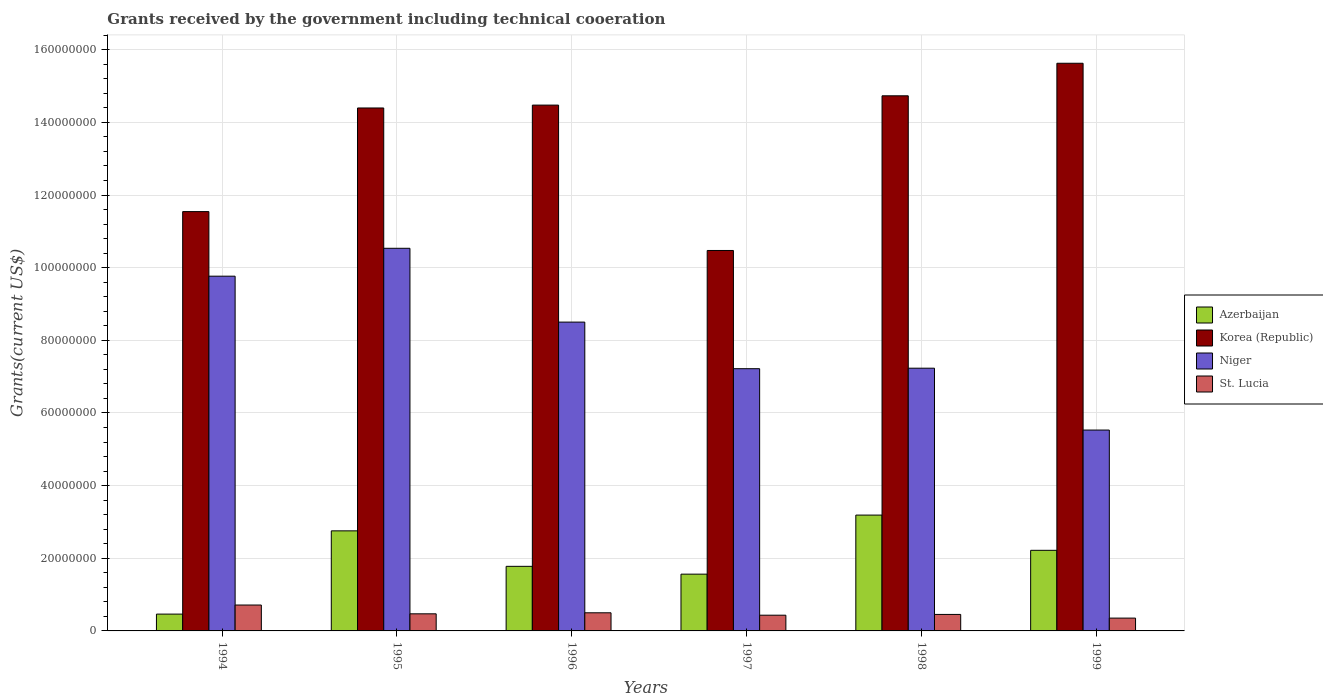How many bars are there on the 4th tick from the left?
Your response must be concise. 4. How many bars are there on the 4th tick from the right?
Make the answer very short. 4. In how many cases, is the number of bars for a given year not equal to the number of legend labels?
Your answer should be compact. 0. What is the total grants received by the government in Niger in 1997?
Offer a very short reply. 7.22e+07. Across all years, what is the maximum total grants received by the government in St. Lucia?
Provide a short and direct response. 7.13e+06. Across all years, what is the minimum total grants received by the government in Niger?
Provide a short and direct response. 5.53e+07. In which year was the total grants received by the government in Korea (Republic) maximum?
Provide a succinct answer. 1999. In which year was the total grants received by the government in Korea (Republic) minimum?
Your answer should be compact. 1997. What is the total total grants received by the government in Azerbaijan in the graph?
Your answer should be compact. 1.20e+08. What is the difference between the total grants received by the government in St. Lucia in 1994 and that in 1996?
Offer a terse response. 2.14e+06. What is the difference between the total grants received by the government in Korea (Republic) in 1998 and the total grants received by the government in St. Lucia in 1995?
Keep it short and to the point. 1.43e+08. What is the average total grants received by the government in Korea (Republic) per year?
Give a very brief answer. 1.35e+08. In the year 1997, what is the difference between the total grants received by the government in St. Lucia and total grants received by the government in Niger?
Your answer should be compact. -6.79e+07. In how many years, is the total grants received by the government in St. Lucia greater than 96000000 US$?
Your response must be concise. 0. What is the ratio of the total grants received by the government in St. Lucia in 1997 to that in 1998?
Offer a very short reply. 0.95. Is the total grants received by the government in Korea (Republic) in 1994 less than that in 1998?
Keep it short and to the point. Yes. What is the difference between the highest and the second highest total grants received by the government in Niger?
Make the answer very short. 7.68e+06. What is the difference between the highest and the lowest total grants received by the government in Niger?
Keep it short and to the point. 5.00e+07. Is the sum of the total grants received by the government in St. Lucia in 1994 and 1996 greater than the maximum total grants received by the government in Niger across all years?
Your answer should be compact. No. Is it the case that in every year, the sum of the total grants received by the government in Niger and total grants received by the government in St. Lucia is greater than the sum of total grants received by the government in Azerbaijan and total grants received by the government in Korea (Republic)?
Provide a short and direct response. No. What does the 2nd bar from the left in 1999 represents?
Offer a very short reply. Korea (Republic). Is it the case that in every year, the sum of the total grants received by the government in Niger and total grants received by the government in Azerbaijan is greater than the total grants received by the government in St. Lucia?
Ensure brevity in your answer.  Yes. How many bars are there?
Give a very brief answer. 24. How many years are there in the graph?
Offer a terse response. 6. What is the difference between two consecutive major ticks on the Y-axis?
Your answer should be very brief. 2.00e+07. Where does the legend appear in the graph?
Keep it short and to the point. Center right. How are the legend labels stacked?
Your answer should be very brief. Vertical. What is the title of the graph?
Offer a very short reply. Grants received by the government including technical cooeration. Does "Germany" appear as one of the legend labels in the graph?
Keep it short and to the point. No. What is the label or title of the X-axis?
Provide a short and direct response. Years. What is the label or title of the Y-axis?
Give a very brief answer. Grants(current US$). What is the Grants(current US$) in Azerbaijan in 1994?
Provide a short and direct response. 4.63e+06. What is the Grants(current US$) of Korea (Republic) in 1994?
Your answer should be very brief. 1.15e+08. What is the Grants(current US$) of Niger in 1994?
Your answer should be compact. 9.77e+07. What is the Grants(current US$) of St. Lucia in 1994?
Ensure brevity in your answer.  7.13e+06. What is the Grants(current US$) in Azerbaijan in 1995?
Your response must be concise. 2.76e+07. What is the Grants(current US$) of Korea (Republic) in 1995?
Ensure brevity in your answer.  1.44e+08. What is the Grants(current US$) of Niger in 1995?
Your response must be concise. 1.05e+08. What is the Grants(current US$) in St. Lucia in 1995?
Offer a very short reply. 4.71e+06. What is the Grants(current US$) of Azerbaijan in 1996?
Your response must be concise. 1.78e+07. What is the Grants(current US$) in Korea (Republic) in 1996?
Keep it short and to the point. 1.45e+08. What is the Grants(current US$) of Niger in 1996?
Give a very brief answer. 8.50e+07. What is the Grants(current US$) in St. Lucia in 1996?
Keep it short and to the point. 4.99e+06. What is the Grants(current US$) in Azerbaijan in 1997?
Provide a short and direct response. 1.56e+07. What is the Grants(current US$) in Korea (Republic) in 1997?
Give a very brief answer. 1.05e+08. What is the Grants(current US$) of Niger in 1997?
Keep it short and to the point. 7.22e+07. What is the Grants(current US$) in St. Lucia in 1997?
Give a very brief answer. 4.33e+06. What is the Grants(current US$) in Azerbaijan in 1998?
Give a very brief answer. 3.19e+07. What is the Grants(current US$) of Korea (Republic) in 1998?
Provide a succinct answer. 1.47e+08. What is the Grants(current US$) of Niger in 1998?
Your response must be concise. 7.23e+07. What is the Grants(current US$) of St. Lucia in 1998?
Make the answer very short. 4.54e+06. What is the Grants(current US$) in Azerbaijan in 1999?
Offer a very short reply. 2.22e+07. What is the Grants(current US$) of Korea (Republic) in 1999?
Provide a succinct answer. 1.56e+08. What is the Grants(current US$) in Niger in 1999?
Keep it short and to the point. 5.53e+07. What is the Grants(current US$) in St. Lucia in 1999?
Keep it short and to the point. 3.53e+06. Across all years, what is the maximum Grants(current US$) in Azerbaijan?
Offer a terse response. 3.19e+07. Across all years, what is the maximum Grants(current US$) in Korea (Republic)?
Provide a succinct answer. 1.56e+08. Across all years, what is the maximum Grants(current US$) of Niger?
Offer a very short reply. 1.05e+08. Across all years, what is the maximum Grants(current US$) of St. Lucia?
Offer a very short reply. 7.13e+06. Across all years, what is the minimum Grants(current US$) in Azerbaijan?
Provide a short and direct response. 4.63e+06. Across all years, what is the minimum Grants(current US$) of Korea (Republic)?
Ensure brevity in your answer.  1.05e+08. Across all years, what is the minimum Grants(current US$) of Niger?
Keep it short and to the point. 5.53e+07. Across all years, what is the minimum Grants(current US$) in St. Lucia?
Your answer should be very brief. 3.53e+06. What is the total Grants(current US$) in Azerbaijan in the graph?
Offer a very short reply. 1.20e+08. What is the total Grants(current US$) in Korea (Republic) in the graph?
Offer a terse response. 8.13e+08. What is the total Grants(current US$) of Niger in the graph?
Offer a terse response. 4.88e+08. What is the total Grants(current US$) in St. Lucia in the graph?
Your answer should be compact. 2.92e+07. What is the difference between the Grants(current US$) in Azerbaijan in 1994 and that in 1995?
Make the answer very short. -2.29e+07. What is the difference between the Grants(current US$) in Korea (Republic) in 1994 and that in 1995?
Ensure brevity in your answer.  -2.85e+07. What is the difference between the Grants(current US$) of Niger in 1994 and that in 1995?
Give a very brief answer. -7.68e+06. What is the difference between the Grants(current US$) in St. Lucia in 1994 and that in 1995?
Provide a short and direct response. 2.42e+06. What is the difference between the Grants(current US$) of Azerbaijan in 1994 and that in 1996?
Provide a succinct answer. -1.32e+07. What is the difference between the Grants(current US$) in Korea (Republic) in 1994 and that in 1996?
Provide a short and direct response. -2.93e+07. What is the difference between the Grants(current US$) of Niger in 1994 and that in 1996?
Make the answer very short. 1.26e+07. What is the difference between the Grants(current US$) of St. Lucia in 1994 and that in 1996?
Offer a terse response. 2.14e+06. What is the difference between the Grants(current US$) of Azerbaijan in 1994 and that in 1997?
Your response must be concise. -1.10e+07. What is the difference between the Grants(current US$) in Korea (Republic) in 1994 and that in 1997?
Provide a succinct answer. 1.07e+07. What is the difference between the Grants(current US$) of Niger in 1994 and that in 1997?
Give a very brief answer. 2.55e+07. What is the difference between the Grants(current US$) in St. Lucia in 1994 and that in 1997?
Offer a very short reply. 2.80e+06. What is the difference between the Grants(current US$) of Azerbaijan in 1994 and that in 1998?
Ensure brevity in your answer.  -2.73e+07. What is the difference between the Grants(current US$) in Korea (Republic) in 1994 and that in 1998?
Your answer should be compact. -3.19e+07. What is the difference between the Grants(current US$) in Niger in 1994 and that in 1998?
Make the answer very short. 2.53e+07. What is the difference between the Grants(current US$) of St. Lucia in 1994 and that in 1998?
Your response must be concise. 2.59e+06. What is the difference between the Grants(current US$) in Azerbaijan in 1994 and that in 1999?
Make the answer very short. -1.76e+07. What is the difference between the Grants(current US$) of Korea (Republic) in 1994 and that in 1999?
Provide a succinct answer. -4.08e+07. What is the difference between the Grants(current US$) in Niger in 1994 and that in 1999?
Provide a short and direct response. 4.24e+07. What is the difference between the Grants(current US$) of St. Lucia in 1994 and that in 1999?
Provide a succinct answer. 3.60e+06. What is the difference between the Grants(current US$) in Azerbaijan in 1995 and that in 1996?
Offer a very short reply. 9.77e+06. What is the difference between the Grants(current US$) in Korea (Republic) in 1995 and that in 1996?
Your response must be concise. -7.90e+05. What is the difference between the Grants(current US$) in Niger in 1995 and that in 1996?
Your answer should be very brief. 2.03e+07. What is the difference between the Grants(current US$) of St. Lucia in 1995 and that in 1996?
Offer a very short reply. -2.80e+05. What is the difference between the Grants(current US$) of Azerbaijan in 1995 and that in 1997?
Keep it short and to the point. 1.19e+07. What is the difference between the Grants(current US$) in Korea (Republic) in 1995 and that in 1997?
Provide a succinct answer. 3.92e+07. What is the difference between the Grants(current US$) in Niger in 1995 and that in 1997?
Provide a succinct answer. 3.32e+07. What is the difference between the Grants(current US$) in St. Lucia in 1995 and that in 1997?
Keep it short and to the point. 3.80e+05. What is the difference between the Grants(current US$) in Azerbaijan in 1995 and that in 1998?
Your answer should be compact. -4.34e+06. What is the difference between the Grants(current US$) of Korea (Republic) in 1995 and that in 1998?
Your answer should be compact. -3.35e+06. What is the difference between the Grants(current US$) of Niger in 1995 and that in 1998?
Make the answer very short. 3.30e+07. What is the difference between the Grants(current US$) in Azerbaijan in 1995 and that in 1999?
Keep it short and to the point. 5.36e+06. What is the difference between the Grants(current US$) in Korea (Republic) in 1995 and that in 1999?
Your response must be concise. -1.23e+07. What is the difference between the Grants(current US$) of Niger in 1995 and that in 1999?
Provide a short and direct response. 5.00e+07. What is the difference between the Grants(current US$) in St. Lucia in 1995 and that in 1999?
Provide a succinct answer. 1.18e+06. What is the difference between the Grants(current US$) in Azerbaijan in 1996 and that in 1997?
Offer a terse response. 2.15e+06. What is the difference between the Grants(current US$) of Korea (Republic) in 1996 and that in 1997?
Offer a terse response. 4.00e+07. What is the difference between the Grants(current US$) in Niger in 1996 and that in 1997?
Give a very brief answer. 1.28e+07. What is the difference between the Grants(current US$) in Azerbaijan in 1996 and that in 1998?
Your answer should be very brief. -1.41e+07. What is the difference between the Grants(current US$) in Korea (Republic) in 1996 and that in 1998?
Make the answer very short. -2.56e+06. What is the difference between the Grants(current US$) in Niger in 1996 and that in 1998?
Offer a terse response. 1.27e+07. What is the difference between the Grants(current US$) in Azerbaijan in 1996 and that in 1999?
Your response must be concise. -4.41e+06. What is the difference between the Grants(current US$) of Korea (Republic) in 1996 and that in 1999?
Provide a succinct answer. -1.15e+07. What is the difference between the Grants(current US$) in Niger in 1996 and that in 1999?
Provide a short and direct response. 2.97e+07. What is the difference between the Grants(current US$) in St. Lucia in 1996 and that in 1999?
Provide a short and direct response. 1.46e+06. What is the difference between the Grants(current US$) of Azerbaijan in 1997 and that in 1998?
Your answer should be very brief. -1.63e+07. What is the difference between the Grants(current US$) of Korea (Republic) in 1997 and that in 1998?
Offer a terse response. -4.26e+07. What is the difference between the Grants(current US$) of Azerbaijan in 1997 and that in 1999?
Your response must be concise. -6.56e+06. What is the difference between the Grants(current US$) of Korea (Republic) in 1997 and that in 1999?
Your answer should be very brief. -5.15e+07. What is the difference between the Grants(current US$) of Niger in 1997 and that in 1999?
Give a very brief answer. 1.69e+07. What is the difference between the Grants(current US$) of Azerbaijan in 1998 and that in 1999?
Keep it short and to the point. 9.70e+06. What is the difference between the Grants(current US$) of Korea (Republic) in 1998 and that in 1999?
Make the answer very short. -8.96e+06. What is the difference between the Grants(current US$) of Niger in 1998 and that in 1999?
Offer a terse response. 1.70e+07. What is the difference between the Grants(current US$) of St. Lucia in 1998 and that in 1999?
Give a very brief answer. 1.01e+06. What is the difference between the Grants(current US$) in Azerbaijan in 1994 and the Grants(current US$) in Korea (Republic) in 1995?
Ensure brevity in your answer.  -1.39e+08. What is the difference between the Grants(current US$) in Azerbaijan in 1994 and the Grants(current US$) in Niger in 1995?
Give a very brief answer. -1.01e+08. What is the difference between the Grants(current US$) of Korea (Republic) in 1994 and the Grants(current US$) of Niger in 1995?
Offer a very short reply. 1.01e+07. What is the difference between the Grants(current US$) of Korea (Republic) in 1994 and the Grants(current US$) of St. Lucia in 1995?
Offer a terse response. 1.11e+08. What is the difference between the Grants(current US$) of Niger in 1994 and the Grants(current US$) of St. Lucia in 1995?
Make the answer very short. 9.30e+07. What is the difference between the Grants(current US$) in Azerbaijan in 1994 and the Grants(current US$) in Korea (Republic) in 1996?
Make the answer very short. -1.40e+08. What is the difference between the Grants(current US$) of Azerbaijan in 1994 and the Grants(current US$) of Niger in 1996?
Provide a short and direct response. -8.04e+07. What is the difference between the Grants(current US$) in Azerbaijan in 1994 and the Grants(current US$) in St. Lucia in 1996?
Give a very brief answer. -3.60e+05. What is the difference between the Grants(current US$) in Korea (Republic) in 1994 and the Grants(current US$) in Niger in 1996?
Your answer should be compact. 3.04e+07. What is the difference between the Grants(current US$) of Korea (Republic) in 1994 and the Grants(current US$) of St. Lucia in 1996?
Your answer should be very brief. 1.10e+08. What is the difference between the Grants(current US$) of Niger in 1994 and the Grants(current US$) of St. Lucia in 1996?
Offer a very short reply. 9.27e+07. What is the difference between the Grants(current US$) of Azerbaijan in 1994 and the Grants(current US$) of Korea (Republic) in 1997?
Your answer should be very brief. -1.00e+08. What is the difference between the Grants(current US$) in Azerbaijan in 1994 and the Grants(current US$) in Niger in 1997?
Make the answer very short. -6.76e+07. What is the difference between the Grants(current US$) of Korea (Republic) in 1994 and the Grants(current US$) of Niger in 1997?
Your answer should be very brief. 4.32e+07. What is the difference between the Grants(current US$) of Korea (Republic) in 1994 and the Grants(current US$) of St. Lucia in 1997?
Your answer should be compact. 1.11e+08. What is the difference between the Grants(current US$) in Niger in 1994 and the Grants(current US$) in St. Lucia in 1997?
Ensure brevity in your answer.  9.33e+07. What is the difference between the Grants(current US$) of Azerbaijan in 1994 and the Grants(current US$) of Korea (Republic) in 1998?
Offer a terse response. -1.43e+08. What is the difference between the Grants(current US$) in Azerbaijan in 1994 and the Grants(current US$) in Niger in 1998?
Offer a terse response. -6.77e+07. What is the difference between the Grants(current US$) of Azerbaijan in 1994 and the Grants(current US$) of St. Lucia in 1998?
Your answer should be very brief. 9.00e+04. What is the difference between the Grants(current US$) in Korea (Republic) in 1994 and the Grants(current US$) in Niger in 1998?
Offer a very short reply. 4.31e+07. What is the difference between the Grants(current US$) in Korea (Republic) in 1994 and the Grants(current US$) in St. Lucia in 1998?
Your answer should be very brief. 1.11e+08. What is the difference between the Grants(current US$) in Niger in 1994 and the Grants(current US$) in St. Lucia in 1998?
Give a very brief answer. 9.31e+07. What is the difference between the Grants(current US$) in Azerbaijan in 1994 and the Grants(current US$) in Korea (Republic) in 1999?
Your answer should be very brief. -1.52e+08. What is the difference between the Grants(current US$) of Azerbaijan in 1994 and the Grants(current US$) of Niger in 1999?
Ensure brevity in your answer.  -5.07e+07. What is the difference between the Grants(current US$) of Azerbaijan in 1994 and the Grants(current US$) of St. Lucia in 1999?
Ensure brevity in your answer.  1.10e+06. What is the difference between the Grants(current US$) of Korea (Republic) in 1994 and the Grants(current US$) of Niger in 1999?
Ensure brevity in your answer.  6.01e+07. What is the difference between the Grants(current US$) of Korea (Republic) in 1994 and the Grants(current US$) of St. Lucia in 1999?
Provide a succinct answer. 1.12e+08. What is the difference between the Grants(current US$) in Niger in 1994 and the Grants(current US$) in St. Lucia in 1999?
Keep it short and to the point. 9.41e+07. What is the difference between the Grants(current US$) in Azerbaijan in 1995 and the Grants(current US$) in Korea (Republic) in 1996?
Provide a succinct answer. -1.17e+08. What is the difference between the Grants(current US$) in Azerbaijan in 1995 and the Grants(current US$) in Niger in 1996?
Your response must be concise. -5.75e+07. What is the difference between the Grants(current US$) in Azerbaijan in 1995 and the Grants(current US$) in St. Lucia in 1996?
Your response must be concise. 2.26e+07. What is the difference between the Grants(current US$) in Korea (Republic) in 1995 and the Grants(current US$) in Niger in 1996?
Your answer should be compact. 5.90e+07. What is the difference between the Grants(current US$) in Korea (Republic) in 1995 and the Grants(current US$) in St. Lucia in 1996?
Make the answer very short. 1.39e+08. What is the difference between the Grants(current US$) in Niger in 1995 and the Grants(current US$) in St. Lucia in 1996?
Ensure brevity in your answer.  1.00e+08. What is the difference between the Grants(current US$) in Azerbaijan in 1995 and the Grants(current US$) in Korea (Republic) in 1997?
Your answer should be very brief. -7.72e+07. What is the difference between the Grants(current US$) of Azerbaijan in 1995 and the Grants(current US$) of Niger in 1997?
Make the answer very short. -4.46e+07. What is the difference between the Grants(current US$) of Azerbaijan in 1995 and the Grants(current US$) of St. Lucia in 1997?
Give a very brief answer. 2.32e+07. What is the difference between the Grants(current US$) in Korea (Republic) in 1995 and the Grants(current US$) in Niger in 1997?
Offer a very short reply. 7.18e+07. What is the difference between the Grants(current US$) in Korea (Republic) in 1995 and the Grants(current US$) in St. Lucia in 1997?
Your answer should be very brief. 1.40e+08. What is the difference between the Grants(current US$) of Niger in 1995 and the Grants(current US$) of St. Lucia in 1997?
Keep it short and to the point. 1.01e+08. What is the difference between the Grants(current US$) of Azerbaijan in 1995 and the Grants(current US$) of Korea (Republic) in 1998?
Provide a succinct answer. -1.20e+08. What is the difference between the Grants(current US$) of Azerbaijan in 1995 and the Grants(current US$) of Niger in 1998?
Keep it short and to the point. -4.48e+07. What is the difference between the Grants(current US$) in Azerbaijan in 1995 and the Grants(current US$) in St. Lucia in 1998?
Your response must be concise. 2.30e+07. What is the difference between the Grants(current US$) of Korea (Republic) in 1995 and the Grants(current US$) of Niger in 1998?
Keep it short and to the point. 7.16e+07. What is the difference between the Grants(current US$) of Korea (Republic) in 1995 and the Grants(current US$) of St. Lucia in 1998?
Give a very brief answer. 1.39e+08. What is the difference between the Grants(current US$) of Niger in 1995 and the Grants(current US$) of St. Lucia in 1998?
Give a very brief answer. 1.01e+08. What is the difference between the Grants(current US$) of Azerbaijan in 1995 and the Grants(current US$) of Korea (Republic) in 1999?
Ensure brevity in your answer.  -1.29e+08. What is the difference between the Grants(current US$) of Azerbaijan in 1995 and the Grants(current US$) of Niger in 1999?
Your response must be concise. -2.78e+07. What is the difference between the Grants(current US$) in Azerbaijan in 1995 and the Grants(current US$) in St. Lucia in 1999?
Give a very brief answer. 2.40e+07. What is the difference between the Grants(current US$) of Korea (Republic) in 1995 and the Grants(current US$) of Niger in 1999?
Offer a terse response. 8.87e+07. What is the difference between the Grants(current US$) of Korea (Republic) in 1995 and the Grants(current US$) of St. Lucia in 1999?
Provide a short and direct response. 1.40e+08. What is the difference between the Grants(current US$) in Niger in 1995 and the Grants(current US$) in St. Lucia in 1999?
Offer a terse response. 1.02e+08. What is the difference between the Grants(current US$) in Azerbaijan in 1996 and the Grants(current US$) in Korea (Republic) in 1997?
Ensure brevity in your answer.  -8.70e+07. What is the difference between the Grants(current US$) of Azerbaijan in 1996 and the Grants(current US$) of Niger in 1997?
Offer a terse response. -5.44e+07. What is the difference between the Grants(current US$) of Azerbaijan in 1996 and the Grants(current US$) of St. Lucia in 1997?
Your answer should be compact. 1.34e+07. What is the difference between the Grants(current US$) of Korea (Republic) in 1996 and the Grants(current US$) of Niger in 1997?
Your answer should be very brief. 7.26e+07. What is the difference between the Grants(current US$) of Korea (Republic) in 1996 and the Grants(current US$) of St. Lucia in 1997?
Offer a terse response. 1.40e+08. What is the difference between the Grants(current US$) of Niger in 1996 and the Grants(current US$) of St. Lucia in 1997?
Provide a succinct answer. 8.07e+07. What is the difference between the Grants(current US$) of Azerbaijan in 1996 and the Grants(current US$) of Korea (Republic) in 1998?
Keep it short and to the point. -1.30e+08. What is the difference between the Grants(current US$) of Azerbaijan in 1996 and the Grants(current US$) of Niger in 1998?
Offer a terse response. -5.46e+07. What is the difference between the Grants(current US$) in Azerbaijan in 1996 and the Grants(current US$) in St. Lucia in 1998?
Your answer should be compact. 1.32e+07. What is the difference between the Grants(current US$) in Korea (Republic) in 1996 and the Grants(current US$) in Niger in 1998?
Provide a short and direct response. 7.24e+07. What is the difference between the Grants(current US$) of Korea (Republic) in 1996 and the Grants(current US$) of St. Lucia in 1998?
Give a very brief answer. 1.40e+08. What is the difference between the Grants(current US$) of Niger in 1996 and the Grants(current US$) of St. Lucia in 1998?
Keep it short and to the point. 8.05e+07. What is the difference between the Grants(current US$) in Azerbaijan in 1996 and the Grants(current US$) in Korea (Republic) in 1999?
Your answer should be very brief. -1.38e+08. What is the difference between the Grants(current US$) of Azerbaijan in 1996 and the Grants(current US$) of Niger in 1999?
Ensure brevity in your answer.  -3.75e+07. What is the difference between the Grants(current US$) in Azerbaijan in 1996 and the Grants(current US$) in St. Lucia in 1999?
Provide a succinct answer. 1.42e+07. What is the difference between the Grants(current US$) of Korea (Republic) in 1996 and the Grants(current US$) of Niger in 1999?
Your answer should be compact. 8.95e+07. What is the difference between the Grants(current US$) of Korea (Republic) in 1996 and the Grants(current US$) of St. Lucia in 1999?
Ensure brevity in your answer.  1.41e+08. What is the difference between the Grants(current US$) of Niger in 1996 and the Grants(current US$) of St. Lucia in 1999?
Offer a terse response. 8.15e+07. What is the difference between the Grants(current US$) of Azerbaijan in 1997 and the Grants(current US$) of Korea (Republic) in 1998?
Your response must be concise. -1.32e+08. What is the difference between the Grants(current US$) of Azerbaijan in 1997 and the Grants(current US$) of Niger in 1998?
Your answer should be very brief. -5.67e+07. What is the difference between the Grants(current US$) in Azerbaijan in 1997 and the Grants(current US$) in St. Lucia in 1998?
Give a very brief answer. 1.11e+07. What is the difference between the Grants(current US$) in Korea (Republic) in 1997 and the Grants(current US$) in Niger in 1998?
Your answer should be very brief. 3.24e+07. What is the difference between the Grants(current US$) of Korea (Republic) in 1997 and the Grants(current US$) of St. Lucia in 1998?
Offer a very short reply. 1.00e+08. What is the difference between the Grants(current US$) of Niger in 1997 and the Grants(current US$) of St. Lucia in 1998?
Make the answer very short. 6.76e+07. What is the difference between the Grants(current US$) in Azerbaijan in 1997 and the Grants(current US$) in Korea (Republic) in 1999?
Provide a succinct answer. -1.41e+08. What is the difference between the Grants(current US$) of Azerbaijan in 1997 and the Grants(current US$) of Niger in 1999?
Your answer should be compact. -3.97e+07. What is the difference between the Grants(current US$) of Azerbaijan in 1997 and the Grants(current US$) of St. Lucia in 1999?
Provide a succinct answer. 1.21e+07. What is the difference between the Grants(current US$) of Korea (Republic) in 1997 and the Grants(current US$) of Niger in 1999?
Offer a very short reply. 4.94e+07. What is the difference between the Grants(current US$) in Korea (Republic) in 1997 and the Grants(current US$) in St. Lucia in 1999?
Offer a terse response. 1.01e+08. What is the difference between the Grants(current US$) of Niger in 1997 and the Grants(current US$) of St. Lucia in 1999?
Provide a succinct answer. 6.87e+07. What is the difference between the Grants(current US$) in Azerbaijan in 1998 and the Grants(current US$) in Korea (Republic) in 1999?
Keep it short and to the point. -1.24e+08. What is the difference between the Grants(current US$) in Azerbaijan in 1998 and the Grants(current US$) in Niger in 1999?
Give a very brief answer. -2.34e+07. What is the difference between the Grants(current US$) of Azerbaijan in 1998 and the Grants(current US$) of St. Lucia in 1999?
Your answer should be very brief. 2.84e+07. What is the difference between the Grants(current US$) in Korea (Republic) in 1998 and the Grants(current US$) in Niger in 1999?
Offer a terse response. 9.20e+07. What is the difference between the Grants(current US$) of Korea (Republic) in 1998 and the Grants(current US$) of St. Lucia in 1999?
Offer a terse response. 1.44e+08. What is the difference between the Grants(current US$) in Niger in 1998 and the Grants(current US$) in St. Lucia in 1999?
Make the answer very short. 6.88e+07. What is the average Grants(current US$) of Azerbaijan per year?
Offer a terse response. 1.99e+07. What is the average Grants(current US$) of Korea (Republic) per year?
Make the answer very short. 1.35e+08. What is the average Grants(current US$) in Niger per year?
Your response must be concise. 8.13e+07. What is the average Grants(current US$) of St. Lucia per year?
Give a very brief answer. 4.87e+06. In the year 1994, what is the difference between the Grants(current US$) of Azerbaijan and Grants(current US$) of Korea (Republic)?
Offer a terse response. -1.11e+08. In the year 1994, what is the difference between the Grants(current US$) in Azerbaijan and Grants(current US$) in Niger?
Ensure brevity in your answer.  -9.30e+07. In the year 1994, what is the difference between the Grants(current US$) of Azerbaijan and Grants(current US$) of St. Lucia?
Provide a short and direct response. -2.50e+06. In the year 1994, what is the difference between the Grants(current US$) in Korea (Republic) and Grants(current US$) in Niger?
Keep it short and to the point. 1.78e+07. In the year 1994, what is the difference between the Grants(current US$) in Korea (Republic) and Grants(current US$) in St. Lucia?
Provide a succinct answer. 1.08e+08. In the year 1994, what is the difference between the Grants(current US$) of Niger and Grants(current US$) of St. Lucia?
Ensure brevity in your answer.  9.05e+07. In the year 1995, what is the difference between the Grants(current US$) of Azerbaijan and Grants(current US$) of Korea (Republic)?
Keep it short and to the point. -1.16e+08. In the year 1995, what is the difference between the Grants(current US$) of Azerbaijan and Grants(current US$) of Niger?
Keep it short and to the point. -7.78e+07. In the year 1995, what is the difference between the Grants(current US$) of Azerbaijan and Grants(current US$) of St. Lucia?
Give a very brief answer. 2.28e+07. In the year 1995, what is the difference between the Grants(current US$) in Korea (Republic) and Grants(current US$) in Niger?
Your answer should be compact. 3.86e+07. In the year 1995, what is the difference between the Grants(current US$) in Korea (Republic) and Grants(current US$) in St. Lucia?
Your answer should be very brief. 1.39e+08. In the year 1995, what is the difference between the Grants(current US$) of Niger and Grants(current US$) of St. Lucia?
Your answer should be compact. 1.01e+08. In the year 1996, what is the difference between the Grants(current US$) of Azerbaijan and Grants(current US$) of Korea (Republic)?
Provide a short and direct response. -1.27e+08. In the year 1996, what is the difference between the Grants(current US$) of Azerbaijan and Grants(current US$) of Niger?
Keep it short and to the point. -6.72e+07. In the year 1996, what is the difference between the Grants(current US$) of Azerbaijan and Grants(current US$) of St. Lucia?
Your answer should be very brief. 1.28e+07. In the year 1996, what is the difference between the Grants(current US$) in Korea (Republic) and Grants(current US$) in Niger?
Make the answer very short. 5.97e+07. In the year 1996, what is the difference between the Grants(current US$) of Korea (Republic) and Grants(current US$) of St. Lucia?
Offer a very short reply. 1.40e+08. In the year 1996, what is the difference between the Grants(current US$) in Niger and Grants(current US$) in St. Lucia?
Provide a short and direct response. 8.00e+07. In the year 1997, what is the difference between the Grants(current US$) in Azerbaijan and Grants(current US$) in Korea (Republic)?
Your answer should be very brief. -8.91e+07. In the year 1997, what is the difference between the Grants(current US$) of Azerbaijan and Grants(current US$) of Niger?
Provide a short and direct response. -5.66e+07. In the year 1997, what is the difference between the Grants(current US$) in Azerbaijan and Grants(current US$) in St. Lucia?
Offer a terse response. 1.13e+07. In the year 1997, what is the difference between the Grants(current US$) of Korea (Republic) and Grants(current US$) of Niger?
Ensure brevity in your answer.  3.26e+07. In the year 1997, what is the difference between the Grants(current US$) in Korea (Republic) and Grants(current US$) in St. Lucia?
Keep it short and to the point. 1.00e+08. In the year 1997, what is the difference between the Grants(current US$) of Niger and Grants(current US$) of St. Lucia?
Make the answer very short. 6.79e+07. In the year 1998, what is the difference between the Grants(current US$) in Azerbaijan and Grants(current US$) in Korea (Republic)?
Offer a very short reply. -1.15e+08. In the year 1998, what is the difference between the Grants(current US$) in Azerbaijan and Grants(current US$) in Niger?
Your answer should be compact. -4.04e+07. In the year 1998, what is the difference between the Grants(current US$) of Azerbaijan and Grants(current US$) of St. Lucia?
Your response must be concise. 2.74e+07. In the year 1998, what is the difference between the Grants(current US$) in Korea (Republic) and Grants(current US$) in Niger?
Provide a short and direct response. 7.50e+07. In the year 1998, what is the difference between the Grants(current US$) of Korea (Republic) and Grants(current US$) of St. Lucia?
Offer a very short reply. 1.43e+08. In the year 1998, what is the difference between the Grants(current US$) in Niger and Grants(current US$) in St. Lucia?
Offer a terse response. 6.78e+07. In the year 1999, what is the difference between the Grants(current US$) of Azerbaijan and Grants(current US$) of Korea (Republic)?
Your response must be concise. -1.34e+08. In the year 1999, what is the difference between the Grants(current US$) of Azerbaijan and Grants(current US$) of Niger?
Make the answer very short. -3.31e+07. In the year 1999, what is the difference between the Grants(current US$) of Azerbaijan and Grants(current US$) of St. Lucia?
Provide a succinct answer. 1.87e+07. In the year 1999, what is the difference between the Grants(current US$) of Korea (Republic) and Grants(current US$) of Niger?
Your response must be concise. 1.01e+08. In the year 1999, what is the difference between the Grants(current US$) in Korea (Republic) and Grants(current US$) in St. Lucia?
Your response must be concise. 1.53e+08. In the year 1999, what is the difference between the Grants(current US$) of Niger and Grants(current US$) of St. Lucia?
Your answer should be very brief. 5.18e+07. What is the ratio of the Grants(current US$) in Azerbaijan in 1994 to that in 1995?
Ensure brevity in your answer.  0.17. What is the ratio of the Grants(current US$) in Korea (Republic) in 1994 to that in 1995?
Keep it short and to the point. 0.8. What is the ratio of the Grants(current US$) of Niger in 1994 to that in 1995?
Offer a very short reply. 0.93. What is the ratio of the Grants(current US$) of St. Lucia in 1994 to that in 1995?
Ensure brevity in your answer.  1.51. What is the ratio of the Grants(current US$) in Azerbaijan in 1994 to that in 1996?
Keep it short and to the point. 0.26. What is the ratio of the Grants(current US$) of Korea (Republic) in 1994 to that in 1996?
Your answer should be compact. 0.8. What is the ratio of the Grants(current US$) of Niger in 1994 to that in 1996?
Offer a very short reply. 1.15. What is the ratio of the Grants(current US$) of St. Lucia in 1994 to that in 1996?
Your response must be concise. 1.43. What is the ratio of the Grants(current US$) in Azerbaijan in 1994 to that in 1997?
Your response must be concise. 0.3. What is the ratio of the Grants(current US$) in Korea (Republic) in 1994 to that in 1997?
Your response must be concise. 1.1. What is the ratio of the Grants(current US$) in Niger in 1994 to that in 1997?
Offer a very short reply. 1.35. What is the ratio of the Grants(current US$) in St. Lucia in 1994 to that in 1997?
Make the answer very short. 1.65. What is the ratio of the Grants(current US$) in Azerbaijan in 1994 to that in 1998?
Ensure brevity in your answer.  0.15. What is the ratio of the Grants(current US$) in Korea (Republic) in 1994 to that in 1998?
Give a very brief answer. 0.78. What is the ratio of the Grants(current US$) of Niger in 1994 to that in 1998?
Ensure brevity in your answer.  1.35. What is the ratio of the Grants(current US$) of St. Lucia in 1994 to that in 1998?
Give a very brief answer. 1.57. What is the ratio of the Grants(current US$) in Azerbaijan in 1994 to that in 1999?
Keep it short and to the point. 0.21. What is the ratio of the Grants(current US$) in Korea (Republic) in 1994 to that in 1999?
Your answer should be very brief. 0.74. What is the ratio of the Grants(current US$) in Niger in 1994 to that in 1999?
Offer a terse response. 1.77. What is the ratio of the Grants(current US$) of St. Lucia in 1994 to that in 1999?
Your answer should be compact. 2.02. What is the ratio of the Grants(current US$) of Azerbaijan in 1995 to that in 1996?
Provide a short and direct response. 1.55. What is the ratio of the Grants(current US$) of Korea (Republic) in 1995 to that in 1996?
Give a very brief answer. 0.99. What is the ratio of the Grants(current US$) of Niger in 1995 to that in 1996?
Offer a very short reply. 1.24. What is the ratio of the Grants(current US$) in St. Lucia in 1995 to that in 1996?
Make the answer very short. 0.94. What is the ratio of the Grants(current US$) in Azerbaijan in 1995 to that in 1997?
Your answer should be compact. 1.76. What is the ratio of the Grants(current US$) in Korea (Republic) in 1995 to that in 1997?
Your answer should be compact. 1.37. What is the ratio of the Grants(current US$) of Niger in 1995 to that in 1997?
Provide a succinct answer. 1.46. What is the ratio of the Grants(current US$) in St. Lucia in 1995 to that in 1997?
Offer a very short reply. 1.09. What is the ratio of the Grants(current US$) of Azerbaijan in 1995 to that in 1998?
Offer a terse response. 0.86. What is the ratio of the Grants(current US$) in Korea (Republic) in 1995 to that in 1998?
Give a very brief answer. 0.98. What is the ratio of the Grants(current US$) in Niger in 1995 to that in 1998?
Keep it short and to the point. 1.46. What is the ratio of the Grants(current US$) in St. Lucia in 1995 to that in 1998?
Your answer should be very brief. 1.04. What is the ratio of the Grants(current US$) in Azerbaijan in 1995 to that in 1999?
Give a very brief answer. 1.24. What is the ratio of the Grants(current US$) of Korea (Republic) in 1995 to that in 1999?
Your answer should be very brief. 0.92. What is the ratio of the Grants(current US$) in Niger in 1995 to that in 1999?
Your answer should be very brief. 1.9. What is the ratio of the Grants(current US$) of St. Lucia in 1995 to that in 1999?
Offer a terse response. 1.33. What is the ratio of the Grants(current US$) of Azerbaijan in 1996 to that in 1997?
Provide a succinct answer. 1.14. What is the ratio of the Grants(current US$) of Korea (Republic) in 1996 to that in 1997?
Offer a terse response. 1.38. What is the ratio of the Grants(current US$) of Niger in 1996 to that in 1997?
Give a very brief answer. 1.18. What is the ratio of the Grants(current US$) in St. Lucia in 1996 to that in 1997?
Ensure brevity in your answer.  1.15. What is the ratio of the Grants(current US$) in Azerbaijan in 1996 to that in 1998?
Your answer should be compact. 0.56. What is the ratio of the Grants(current US$) of Korea (Republic) in 1996 to that in 1998?
Keep it short and to the point. 0.98. What is the ratio of the Grants(current US$) in Niger in 1996 to that in 1998?
Offer a terse response. 1.18. What is the ratio of the Grants(current US$) of St. Lucia in 1996 to that in 1998?
Make the answer very short. 1.1. What is the ratio of the Grants(current US$) in Azerbaijan in 1996 to that in 1999?
Give a very brief answer. 0.8. What is the ratio of the Grants(current US$) in Korea (Republic) in 1996 to that in 1999?
Keep it short and to the point. 0.93. What is the ratio of the Grants(current US$) of Niger in 1996 to that in 1999?
Keep it short and to the point. 1.54. What is the ratio of the Grants(current US$) in St. Lucia in 1996 to that in 1999?
Your answer should be very brief. 1.41. What is the ratio of the Grants(current US$) of Azerbaijan in 1997 to that in 1998?
Your answer should be very brief. 0.49. What is the ratio of the Grants(current US$) of Korea (Republic) in 1997 to that in 1998?
Offer a terse response. 0.71. What is the ratio of the Grants(current US$) in Niger in 1997 to that in 1998?
Keep it short and to the point. 1. What is the ratio of the Grants(current US$) of St. Lucia in 1997 to that in 1998?
Provide a short and direct response. 0.95. What is the ratio of the Grants(current US$) of Azerbaijan in 1997 to that in 1999?
Give a very brief answer. 0.7. What is the ratio of the Grants(current US$) of Korea (Republic) in 1997 to that in 1999?
Your answer should be very brief. 0.67. What is the ratio of the Grants(current US$) in Niger in 1997 to that in 1999?
Keep it short and to the point. 1.31. What is the ratio of the Grants(current US$) in St. Lucia in 1997 to that in 1999?
Offer a terse response. 1.23. What is the ratio of the Grants(current US$) in Azerbaijan in 1998 to that in 1999?
Provide a short and direct response. 1.44. What is the ratio of the Grants(current US$) in Korea (Republic) in 1998 to that in 1999?
Your response must be concise. 0.94. What is the ratio of the Grants(current US$) in Niger in 1998 to that in 1999?
Your response must be concise. 1.31. What is the ratio of the Grants(current US$) of St. Lucia in 1998 to that in 1999?
Give a very brief answer. 1.29. What is the difference between the highest and the second highest Grants(current US$) in Azerbaijan?
Offer a very short reply. 4.34e+06. What is the difference between the highest and the second highest Grants(current US$) in Korea (Republic)?
Offer a terse response. 8.96e+06. What is the difference between the highest and the second highest Grants(current US$) of Niger?
Provide a succinct answer. 7.68e+06. What is the difference between the highest and the second highest Grants(current US$) of St. Lucia?
Provide a succinct answer. 2.14e+06. What is the difference between the highest and the lowest Grants(current US$) of Azerbaijan?
Provide a short and direct response. 2.73e+07. What is the difference between the highest and the lowest Grants(current US$) in Korea (Republic)?
Your answer should be very brief. 5.15e+07. What is the difference between the highest and the lowest Grants(current US$) of Niger?
Make the answer very short. 5.00e+07. What is the difference between the highest and the lowest Grants(current US$) in St. Lucia?
Offer a very short reply. 3.60e+06. 